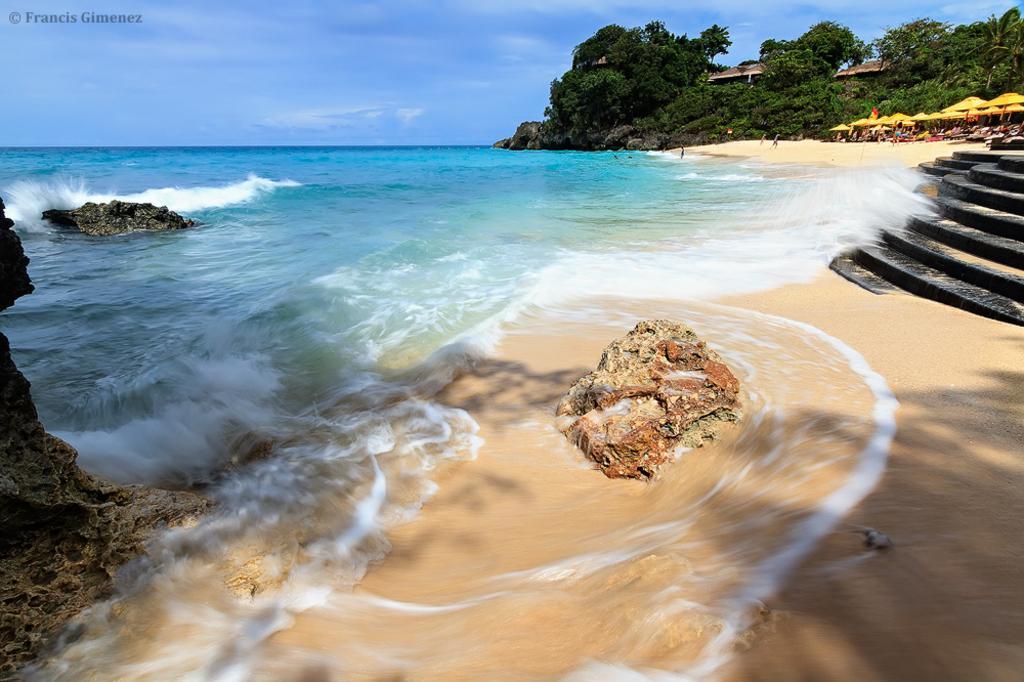Can you describe this image briefly? In the picture we can see an ocean and near to it, we can see a sand and rock on it and in the background, we can see some umbrellas and chairs under it and behind it we can see trees and sky with clouds. 